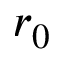<formula> <loc_0><loc_0><loc_500><loc_500>r _ { 0 }</formula> 